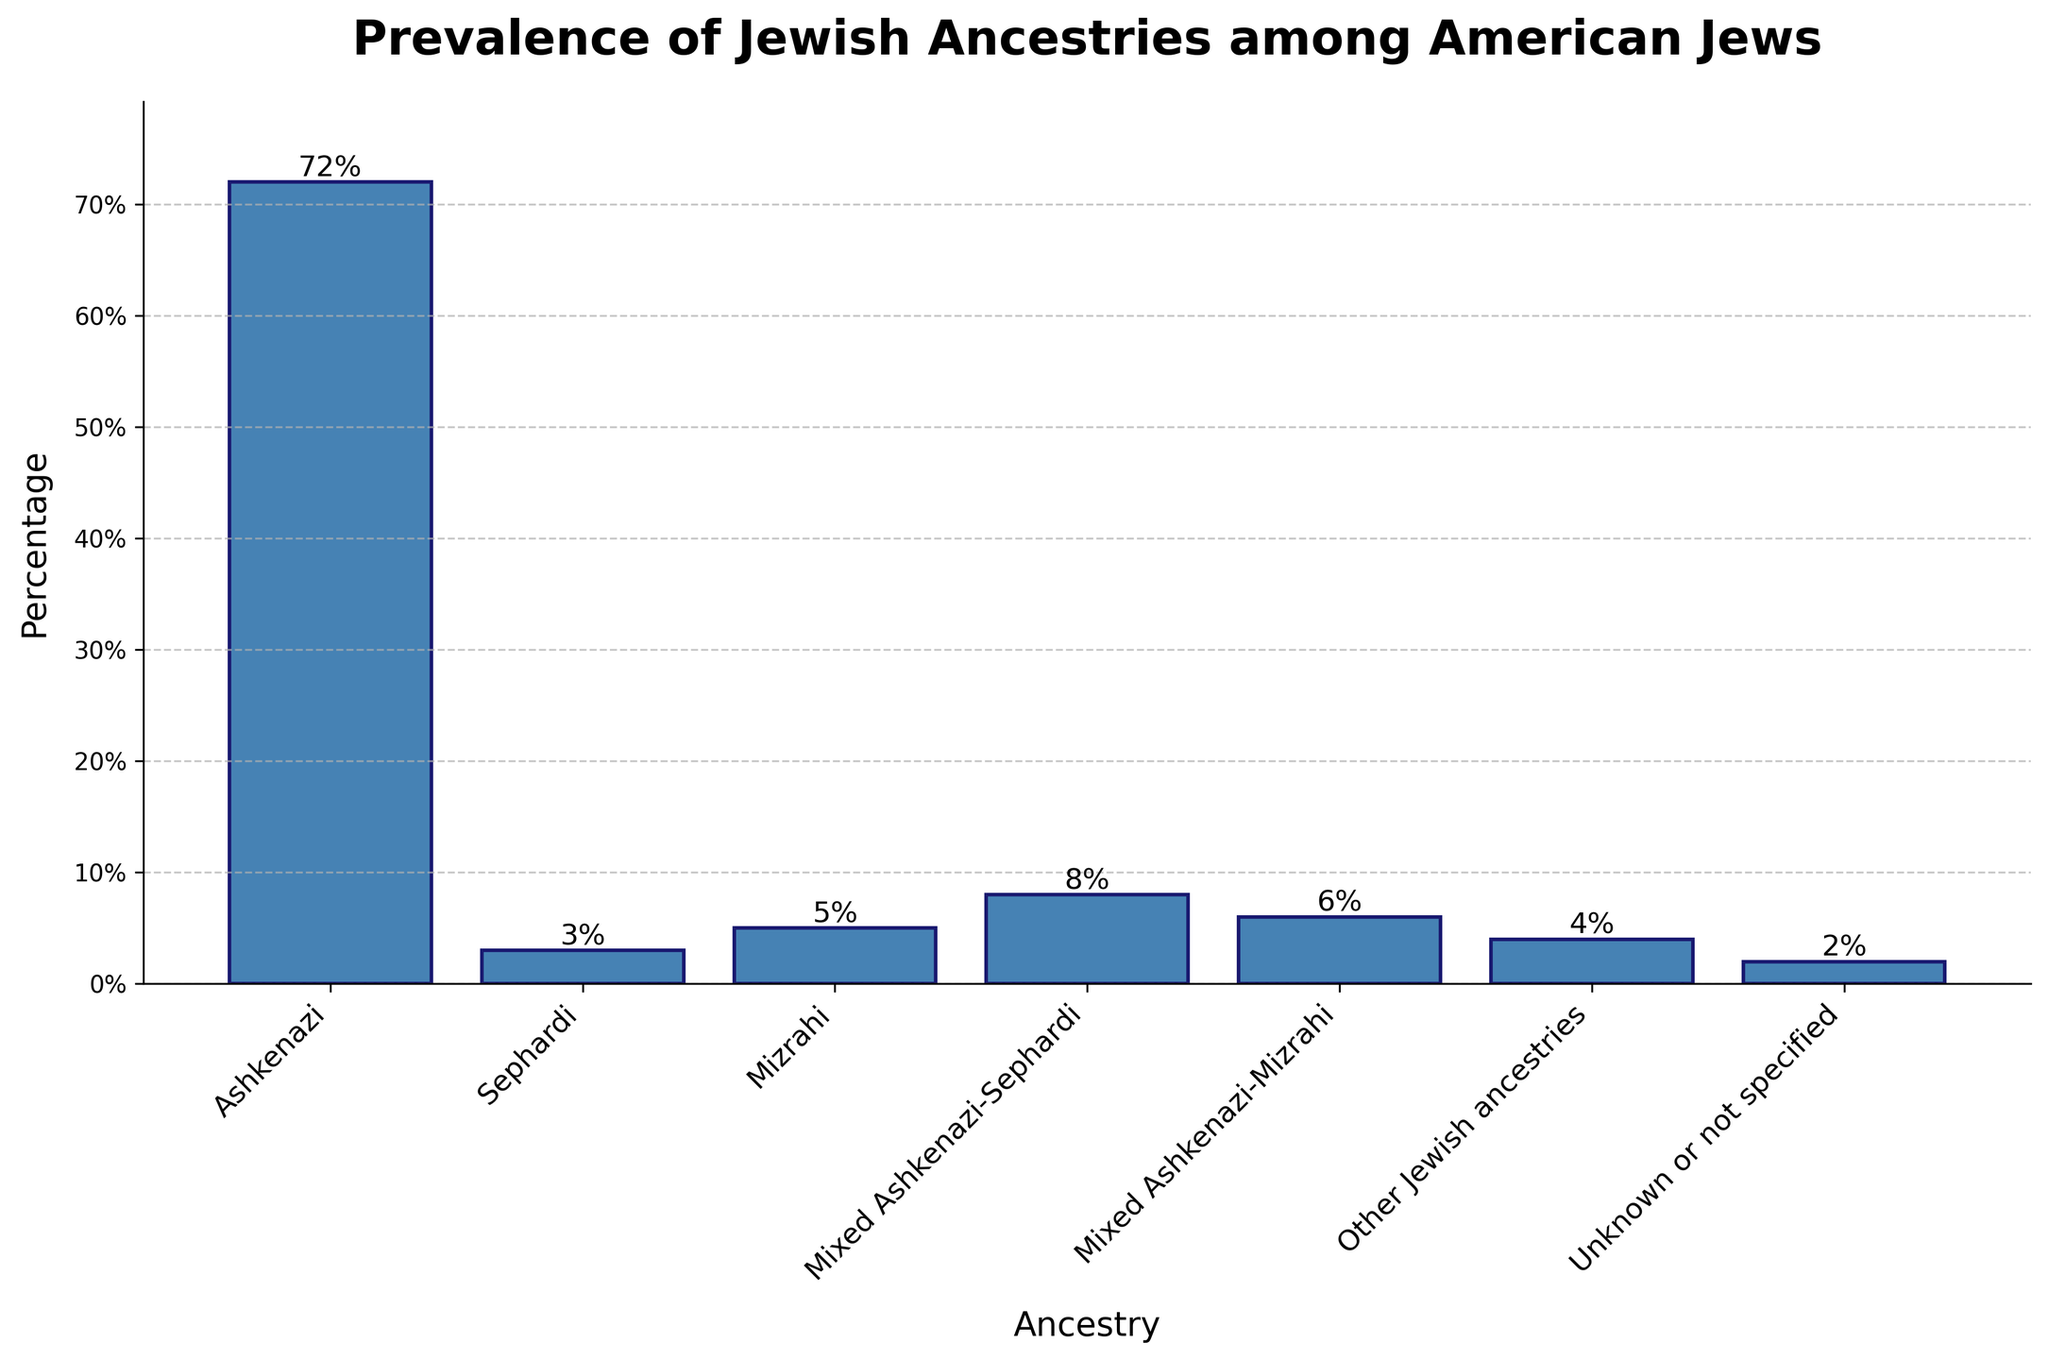What is the percentage of American Jews with Ashkenazi ancestry? To find the percentage of American Jews with Ashkenazi ancestry, look at the bar labeled "Ashkenazi" in the figure. The percentage label on top of the bar indicates the exact value.
Answer: 72% What is the combined percentage of American Jews with Sephardi ancestry and Mizrahi ancestry? To determine the combined percentage, add the percentage values of the bars labeled "Sephardi" and "Mizrahi" from the graph. The Sephardi percentage is 3%, and the Mizrahi percentage is 5%, so their sum is 3% + 5%.
Answer: 8% How does the prevalence of Mixed Ashkenazi-Sephardi compare to Mixed Ashkenazi-Mizrahi ancestries among American Jews? To compare these prevalences, examine the heights of the bars labeled "Mixed Ashkenazi-Sephardi" and "Mixed Ashkenazi-Mizrahi". Check their percentage values, which are 8% and 6% respectively. "Mixed Ashkenazi-Sephardi" has a higher percentage.
Answer: Mixed Ashkenazi-Sephardi is higher What is the percentage difference between American Jews with Ashkenazi ancestry and those with Mizrahi ancestry? Subtract the percentage of "Mizrahi" from the percentage of "Ashkenazi" to find the difference (72% - 5%).
Answer: 67% What is more prevalent: Jews with Ashkenazi ancestry or all other specified ancestries combined? First, add the percentages of all ancestries except Ashkenazi: 3% (Sephardi) + 5% (Mizrahi) + 8% (Mixed Ashkenazi-Sephardi) + 6% (Mixed Ashkenazi-Mizrahi) + 4% (Other Jewish ancestries). This total is 26%. Since Ashkenazi alone is 72%, Ashkenazi is more prevalent.
Answer: Ashkenazi How many ancestries have a prevalence of more than 5%? Identify the bars with percentages greater than 5%. These are "Ashkenazi" (72%), "Mixed Ashkenazi-Sephardi" (8%), and "Mixed Ashkenazi-Mizrahi" (6%). Thus, there are 3 ancestries.
Answer: 3 What is the least prevalent ancestry among American Jews? Observe the shortest bar in the chart and read its label. The one with the smallest percentage is labeled "Unknown or not specified" with 2%.
Answer: Unknown or not specified Of the ancestries identified, which one has a prevalence closest to the median value of all given percentages? First, list the percentages in ascending order: 2%, 3%, 4%, 5%, 6%, 8%, 72%. The median value (middle value of the sorted list) is 5%, which corresponds to "Mizrahi".
Answer: Mizrahi What is the combined percentage of American Jews with mixed ancestries (Mixed Ashkenazi-Sephardi and Mixed Ashkenazi-Mizrahi)? Add the percentages for "Mixed Ashkenazi-Sephardi" and "Mixed Ashkenazi-Mizrahi": 8% + 6%.
Answer: 14% 